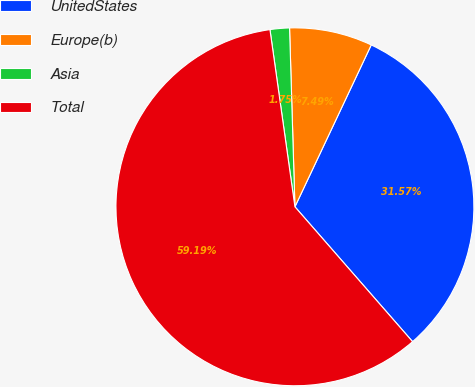<chart> <loc_0><loc_0><loc_500><loc_500><pie_chart><fcel>UnitedStates<fcel>Europe(b)<fcel>Asia<fcel>Total<nl><fcel>31.57%<fcel>7.49%<fcel>1.75%<fcel>59.19%<nl></chart> 